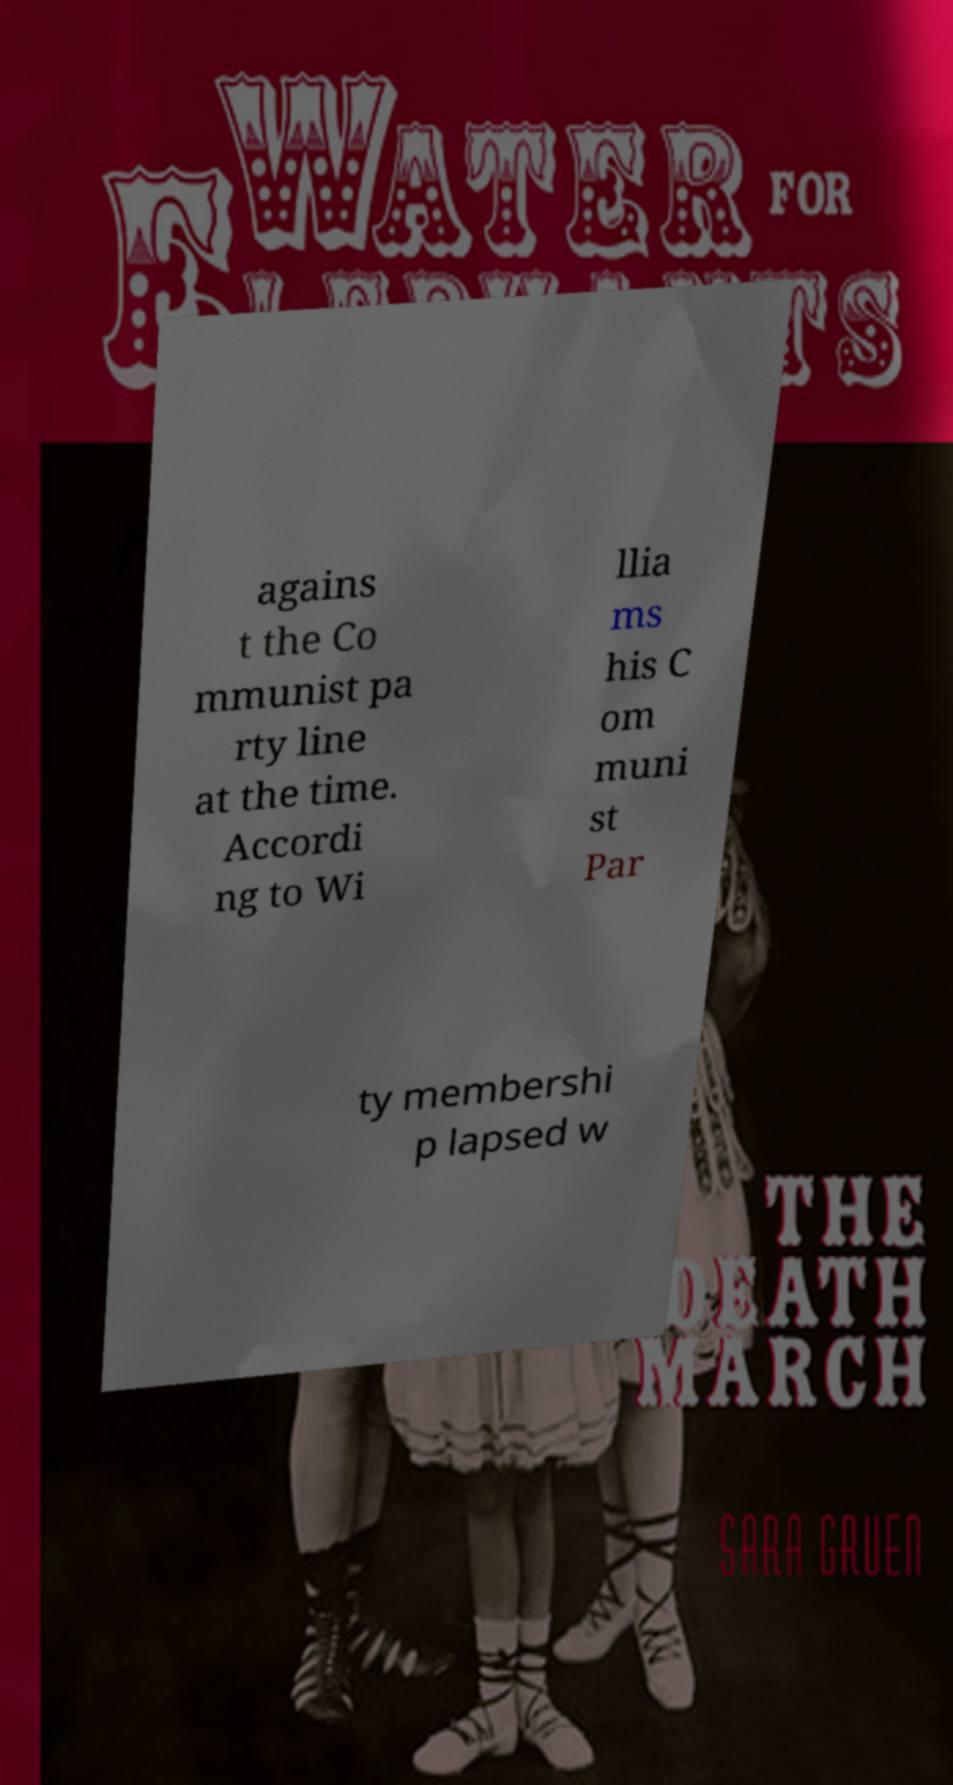What messages or text are displayed in this image? I need them in a readable, typed format. agains t the Co mmunist pa rty line at the time. Accordi ng to Wi llia ms his C om muni st Par ty membershi p lapsed w 